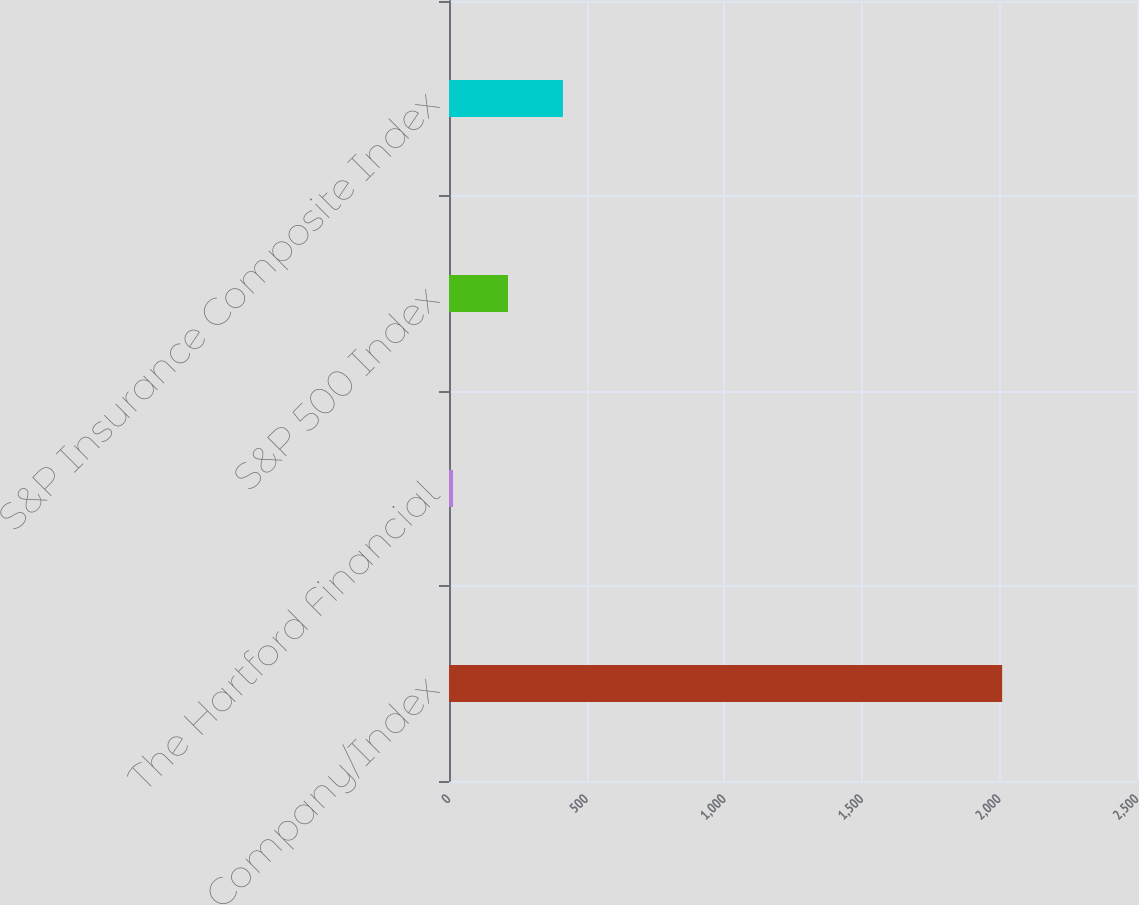Convert chart to OTSL. <chart><loc_0><loc_0><loc_500><loc_500><bar_chart><fcel>Company/Index<fcel>The Hartford Financial<fcel>S&P 500 Index<fcel>S&P Insurance Composite Index<nl><fcel>2010<fcel>14.89<fcel>214.4<fcel>413.91<nl></chart> 